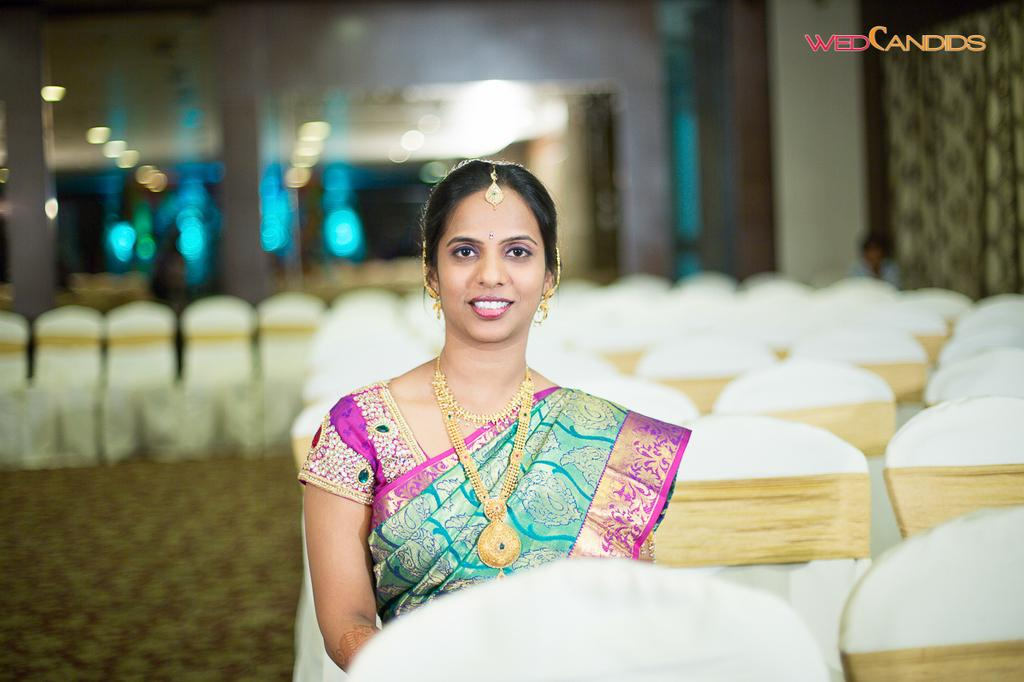Who is the main subject in the image? There is a bride in the image. What type of clothing is the bride wearing? The bride is wearing a saree. Are there any accessories visible on the bride? Yes, the bride is wearing jewels. What is the bride's posture in the image? The bride is sitting on a chair. Can you describe the background of the image? There are many chairs in the background of the image. What type of bath is the bride taking in the image? There is no indication of a bath in the image; the bride is sitting on a chair and wearing a saree and jewels. 